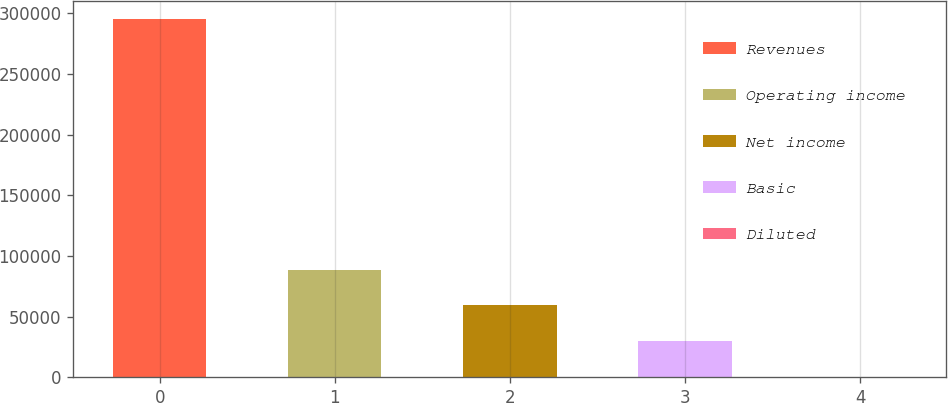Convert chart to OTSL. <chart><loc_0><loc_0><loc_500><loc_500><bar_chart><fcel>Revenues<fcel>Operating income<fcel>Net income<fcel>Basic<fcel>Diluted<nl><fcel>295833<fcel>88750<fcel>59166.8<fcel>29583.5<fcel>0.19<nl></chart> 